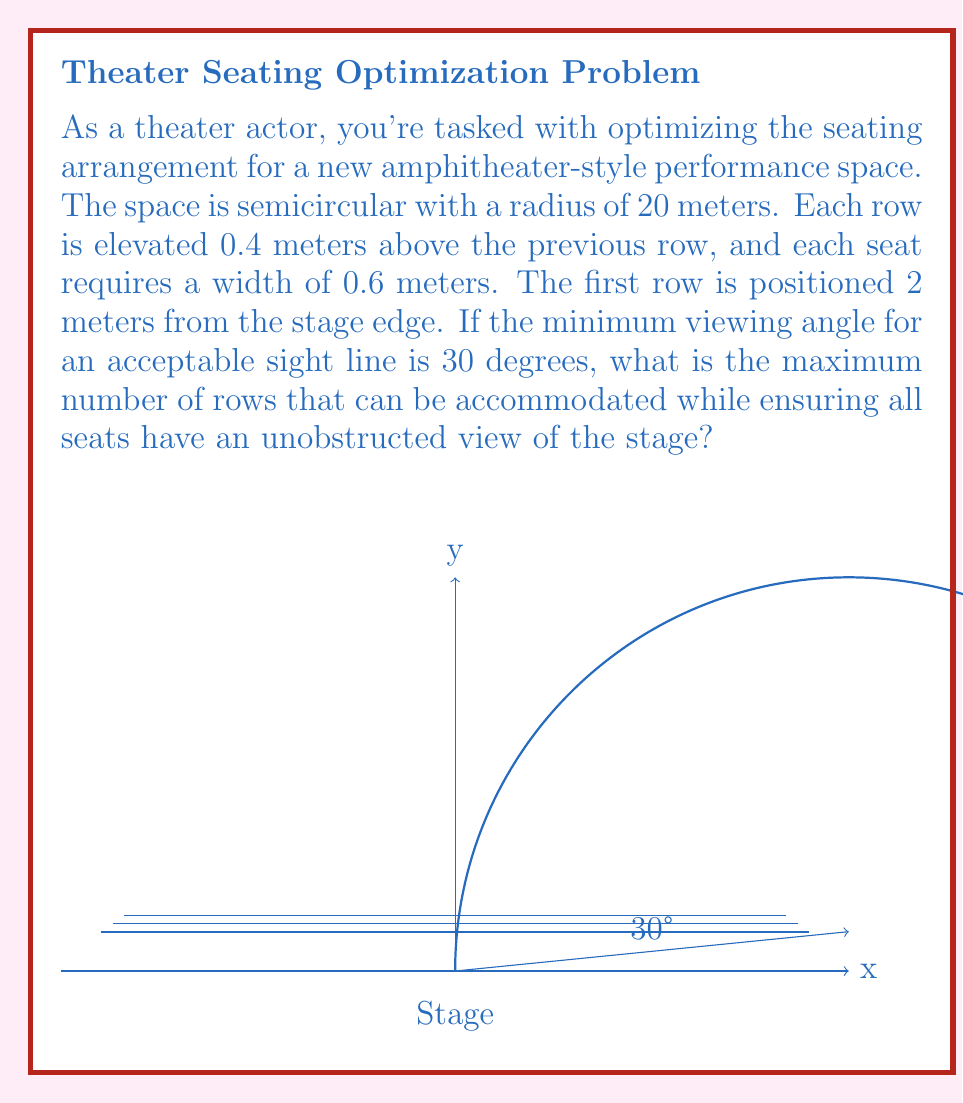Can you answer this question? Let's approach this problem step-by-step:

1) First, we need to determine the height of each row relative to the stage. Let $n$ be the row number, starting from 0 for the first row. The height of the $n$-th row is:

   $h(n) = 2 + 0.4n$ meters

2) The radius of the semicircle at each row is:

   $r(n) = \sqrt{20^2 - h(n)^2}$ meters

3) The number of seats in each row is:

   $seats(n) = \left\lfloor\frac{2\pi r(n)}{2 \cdot 0.6}\right\rfloor$

   We divide by 2 because it's a semicircle, and by 0.6 for the seat width.

4) For the sight line, we need to ensure that the angle from the edge of the stage to each seat is at least 30°. This angle $\theta$ for the $n$-th row is:

   $\theta(n) = \arctan\left(\frac{h(n)}{20}\right)$

5) We need to find the maximum $n$ such that $\theta(n) \geq 30°$:

   $30° \leq \arctan\left(\frac{2 + 0.4n}{20}\right)$

   Solving this inequality:

   $\tan(30°) \leq \frac{2 + 0.4n}{20}$
   $20 \tan(30°) - 2 \leq 0.4n$
   $n \leq \frac{20 \tan(30°) - 2}{0.4} \approx 26.8$

6) Therefore, the maximum number of rows is 26, as we need to round down to ensure all seats have an acceptable view.
Answer: 26 rows 